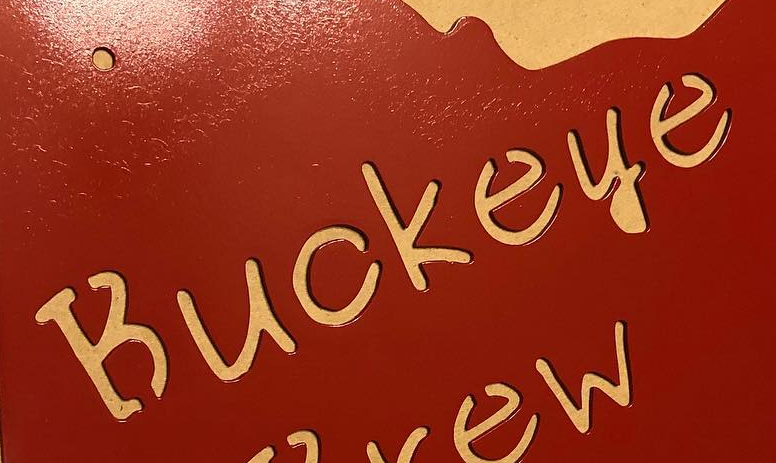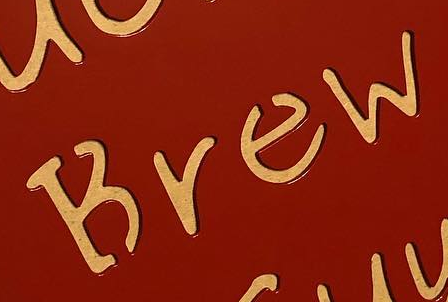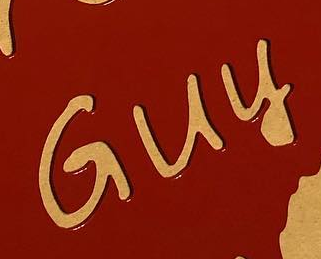Read the text content from these images in order, separated by a semicolon. Buckeye; Brew; Guy 